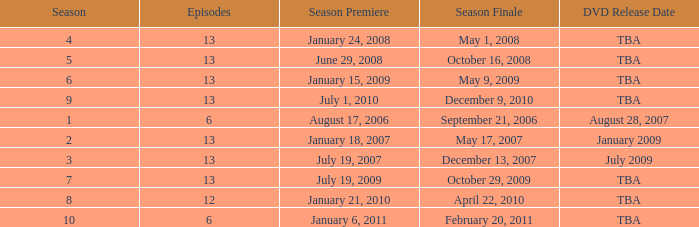On what date was the DVD released for the season with fewer than 13 episodes that aired before season 8? August 28, 2007. 